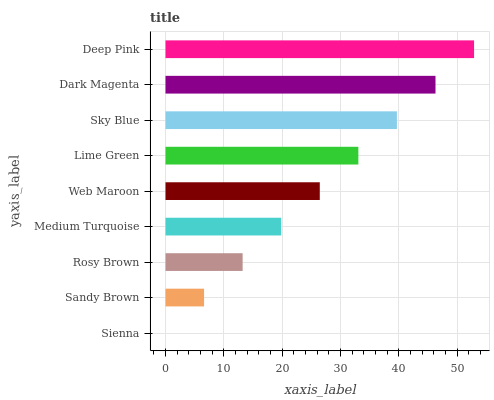Is Sienna the minimum?
Answer yes or no. Yes. Is Deep Pink the maximum?
Answer yes or no. Yes. Is Sandy Brown the minimum?
Answer yes or no. No. Is Sandy Brown the maximum?
Answer yes or no. No. Is Sandy Brown greater than Sienna?
Answer yes or no. Yes. Is Sienna less than Sandy Brown?
Answer yes or no. Yes. Is Sienna greater than Sandy Brown?
Answer yes or no. No. Is Sandy Brown less than Sienna?
Answer yes or no. No. Is Web Maroon the high median?
Answer yes or no. Yes. Is Web Maroon the low median?
Answer yes or no. Yes. Is Rosy Brown the high median?
Answer yes or no. No. Is Rosy Brown the low median?
Answer yes or no. No. 